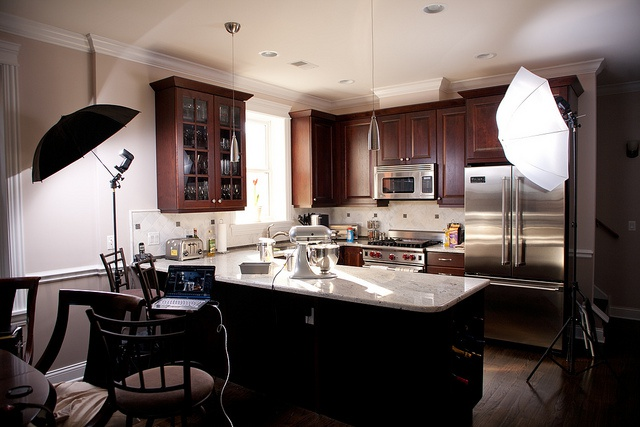Describe the objects in this image and their specific colors. I can see dining table in black, lightgray, and darkgray tones, refrigerator in black, gray, and darkgray tones, chair in black, brown, and gray tones, chair in black, gray, and darkgray tones, and umbrella in black, white, darkgray, and gray tones in this image. 